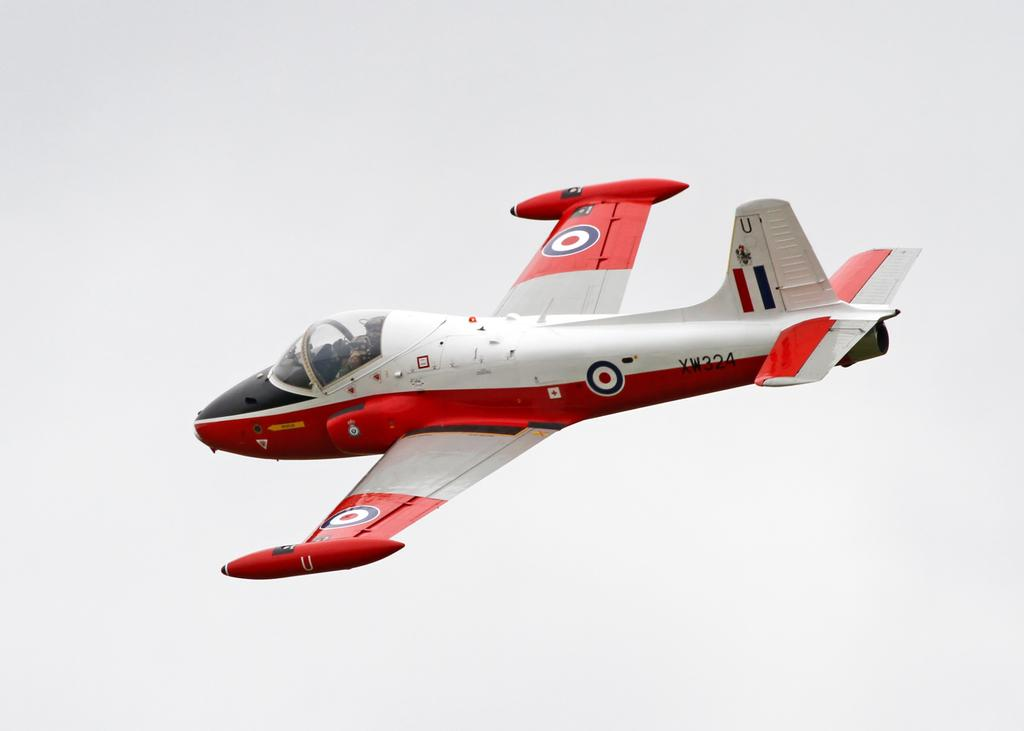<image>
Describe the image concisely. A red and white airplane has a letter U on the tail fin. 